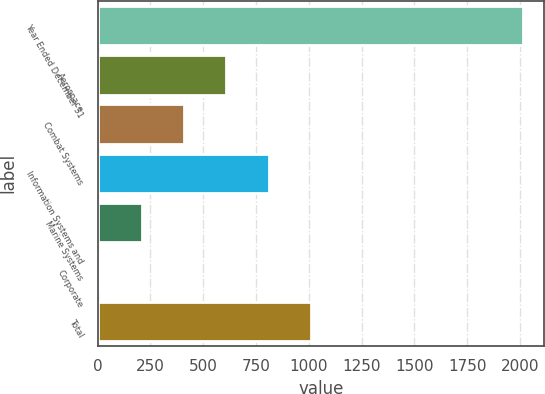Convert chart to OTSL. <chart><loc_0><loc_0><loc_500><loc_500><bar_chart><fcel>Year Ended December 31<fcel>Aerospace<fcel>Combat Systems<fcel>Information Systems and<fcel>Marine Systems<fcel>Corporate<fcel>Total<nl><fcel>2013<fcel>609.5<fcel>409<fcel>810<fcel>208.5<fcel>8<fcel>1010.5<nl></chart> 